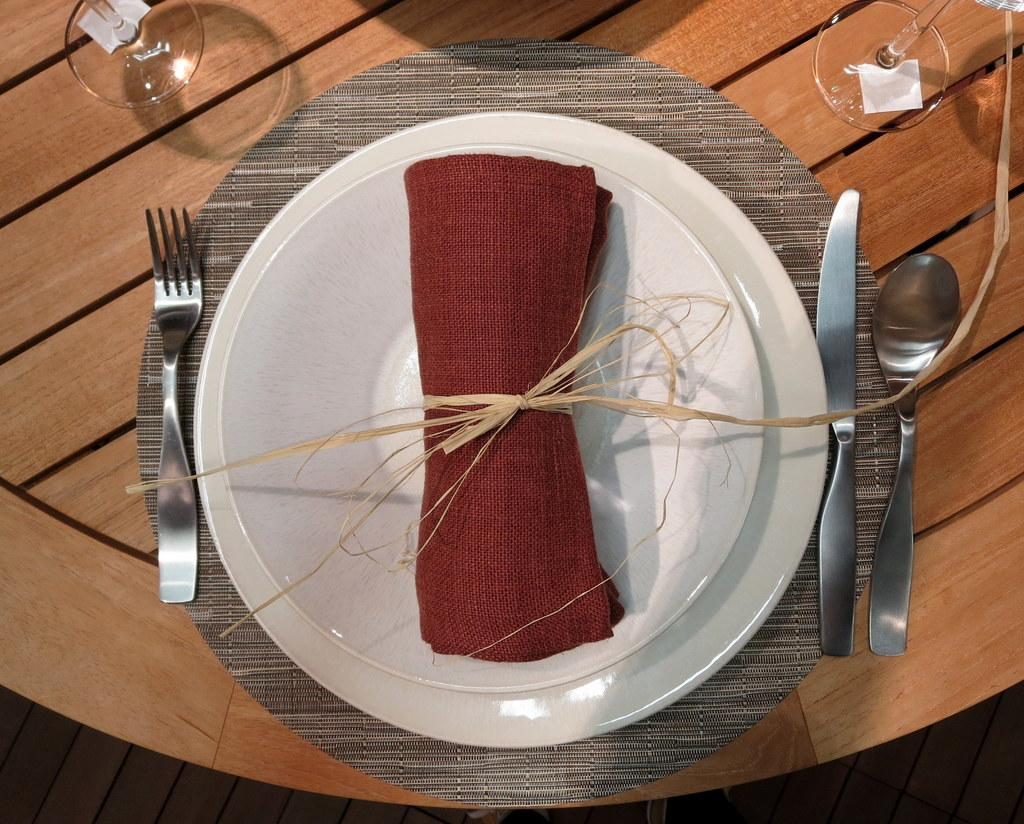What piece of furniture is visible in the image? There is a table in the image. What is placed on the table? There is a plate, a knife, a spoon, a fork, and two glasses on the table. What is in the plate? There is a cloth in the plate. How many cherries are on the earth in the image? There are no cherries or references to the earth present in the image. 